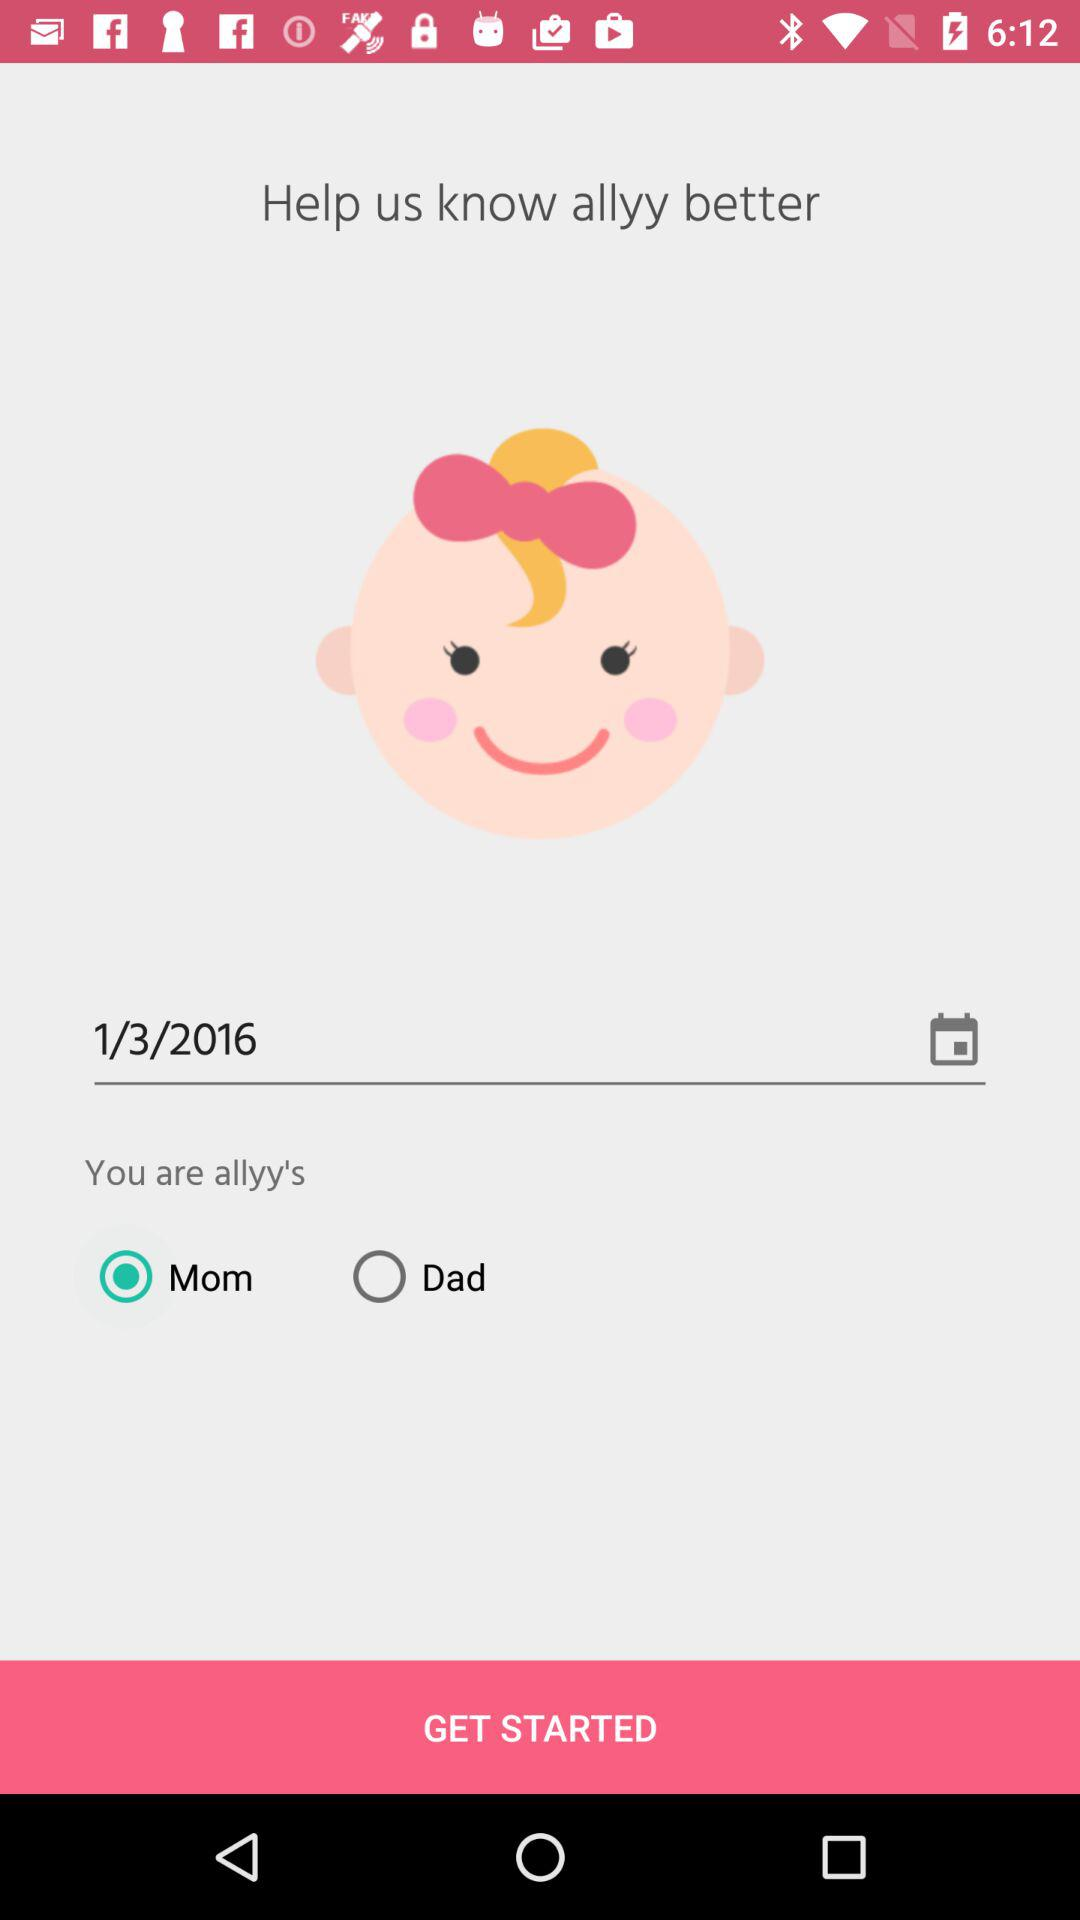What are the options provided for "You are allyy's"? The provided options are "Mom" and "Dad". 